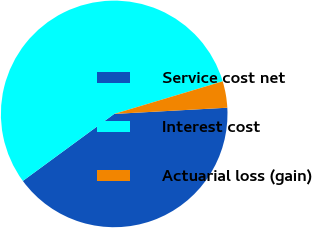Convert chart to OTSL. <chart><loc_0><loc_0><loc_500><loc_500><pie_chart><fcel>Service cost net<fcel>Interest cost<fcel>Actuarial loss (gain)<nl><fcel>40.8%<fcel>55.43%<fcel>3.77%<nl></chart> 